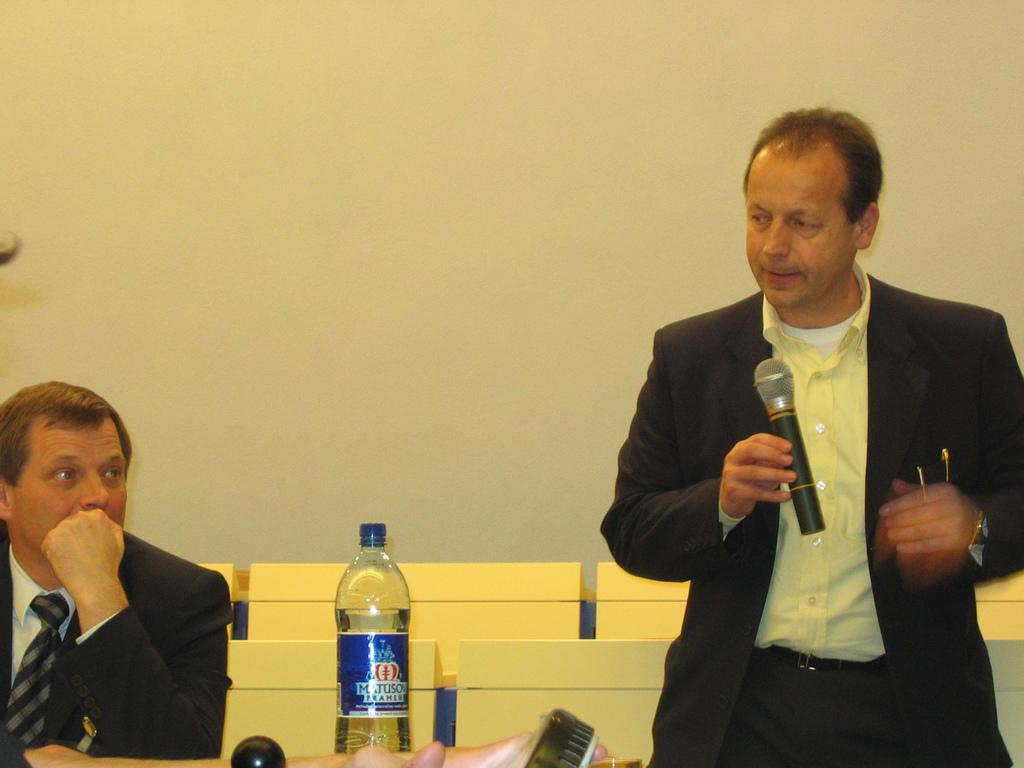How many people are in the image? There are two people in the image. What are the positions of the people in the image? One person is standing and holding a microphone, while the other person is sitting on a chair. What object is present on the table in the image? There is a bottle on the table. What might the standing person be doing with the microphone? The standing person might be using the microphone for speaking or singing. What type of doll is sitting on the chair next to the person in the image? There is no doll present in the image; the person sitting on the chair is a human. 